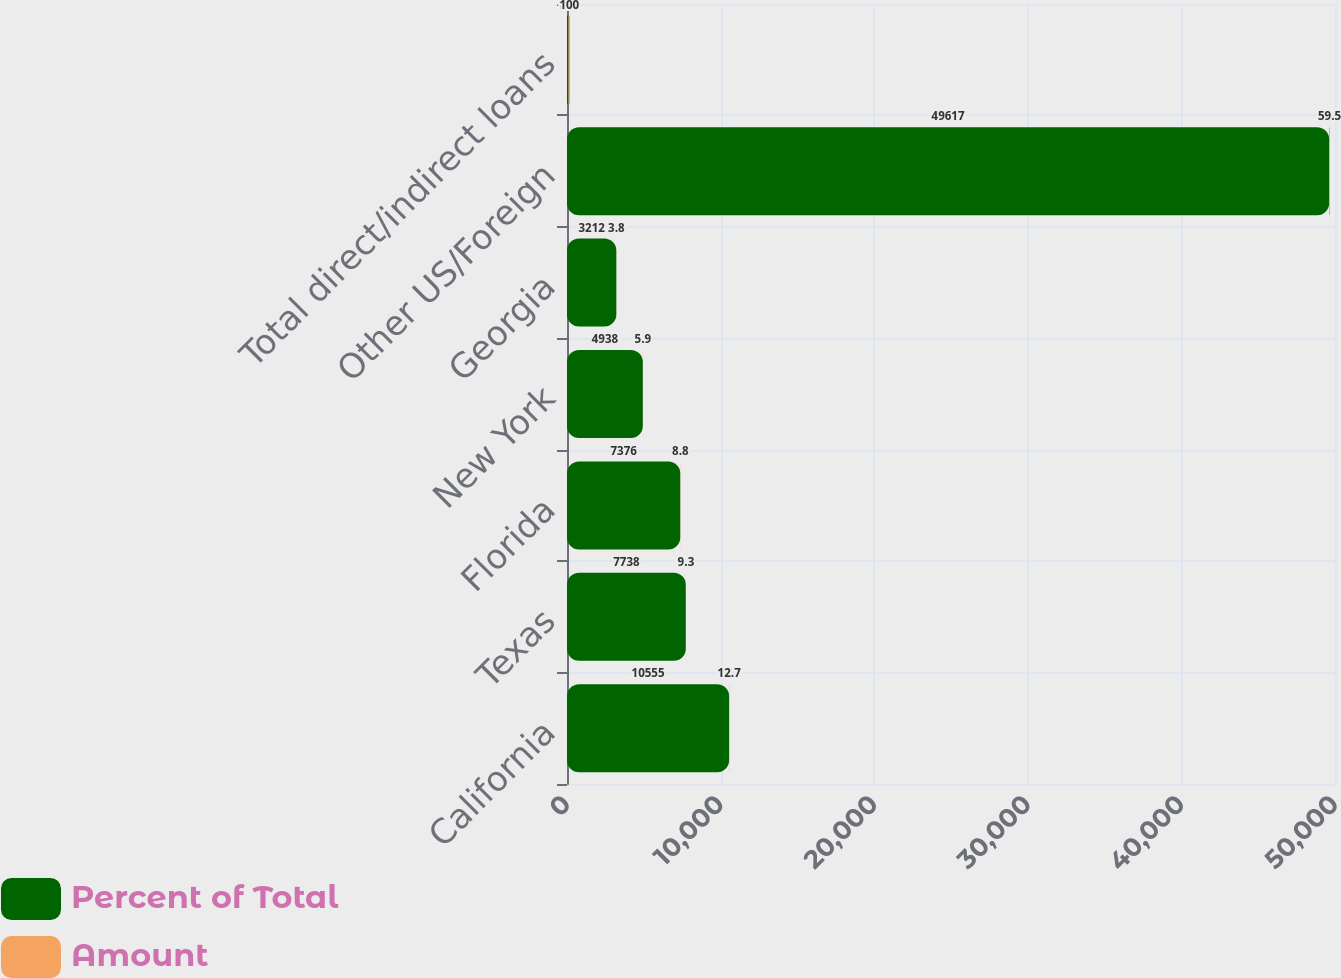Convert chart to OTSL. <chart><loc_0><loc_0><loc_500><loc_500><stacked_bar_chart><ecel><fcel>California<fcel>Texas<fcel>Florida<fcel>New York<fcel>Georgia<fcel>Other US/Foreign<fcel>Total direct/indirect loans<nl><fcel>Percent of Total<fcel>10555<fcel>7738<fcel>7376<fcel>4938<fcel>3212<fcel>49617<fcel>100<nl><fcel>Amount<fcel>12.7<fcel>9.3<fcel>8.8<fcel>5.9<fcel>3.8<fcel>59.5<fcel>100<nl></chart> 